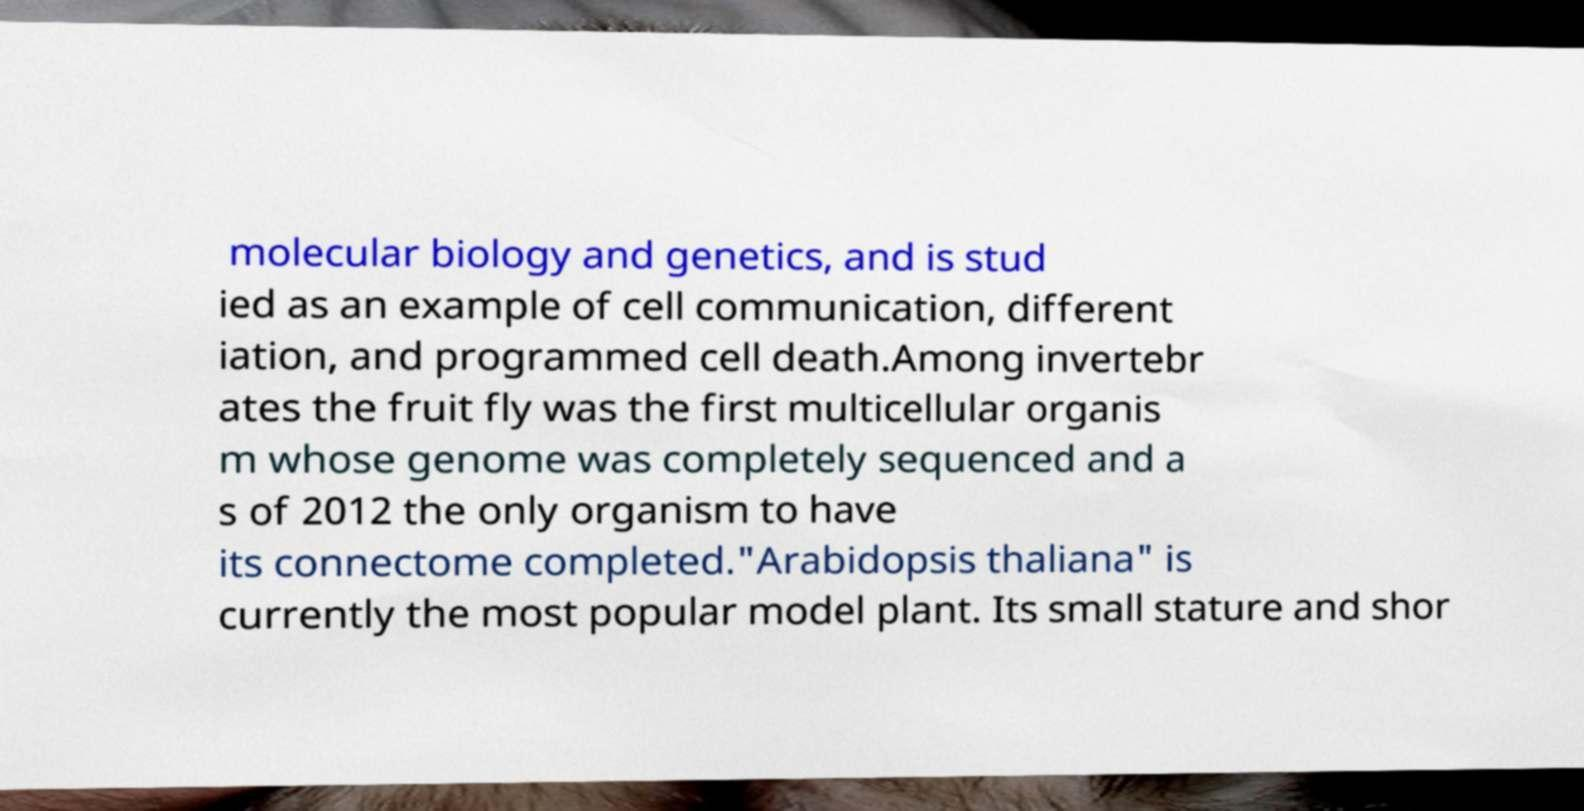Can you read and provide the text displayed in the image?This photo seems to have some interesting text. Can you extract and type it out for me? molecular biology and genetics, and is stud ied as an example of cell communication, different iation, and programmed cell death.Among invertebr ates the fruit fly was the first multicellular organis m whose genome was completely sequenced and a s of 2012 the only organism to have its connectome completed."Arabidopsis thaliana" is currently the most popular model plant. Its small stature and shor 